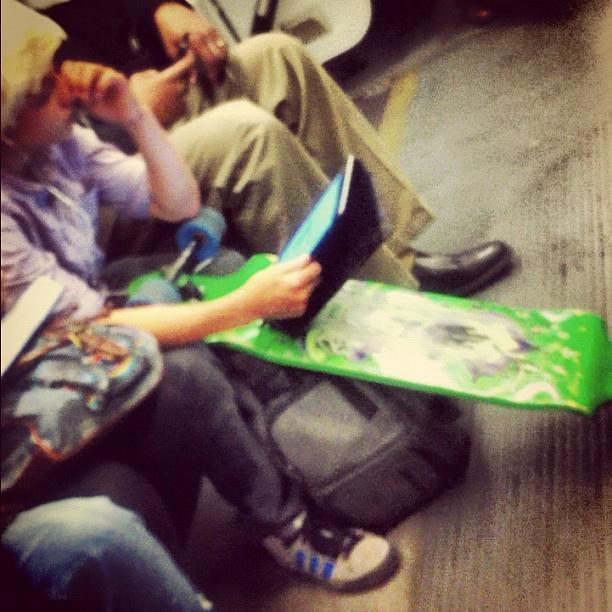How many blue stripes are on the white shoe?
Give a very brief answer. 3. How many people are visible?
Give a very brief answer. 3. 